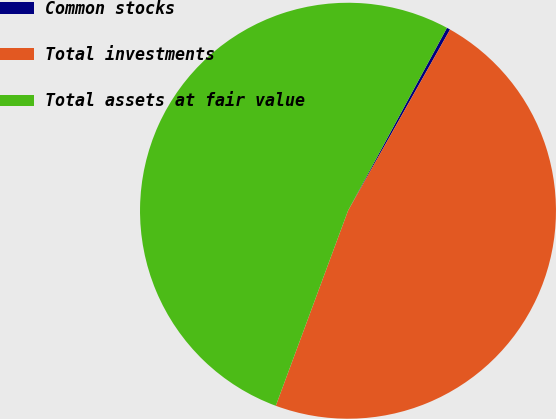Convert chart to OTSL. <chart><loc_0><loc_0><loc_500><loc_500><pie_chart><fcel>Common stocks<fcel>Total investments<fcel>Total assets at fair value<nl><fcel>0.27%<fcel>47.48%<fcel>52.25%<nl></chart> 